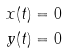Convert formula to latex. <formula><loc_0><loc_0><loc_500><loc_500>x ( t ) & = 0 \\ y ( t ) & = 0</formula> 